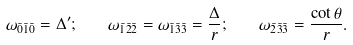<formula> <loc_0><loc_0><loc_500><loc_500>\omega _ { \bar { 0 } \bar { 1 } \bar { 0 } } = \Delta ^ { \prime } ; \quad \omega _ { \bar { 1 } \bar { 2 } \bar { 2 } } = \omega _ { \bar { 1 } \bar { 3 } \bar { 3 } } = \frac { \Delta } { r } ; \quad \omega _ { \bar { 2 } \bar { 3 } \bar { 3 } } = \frac { \cot \theta } { r } .</formula> 